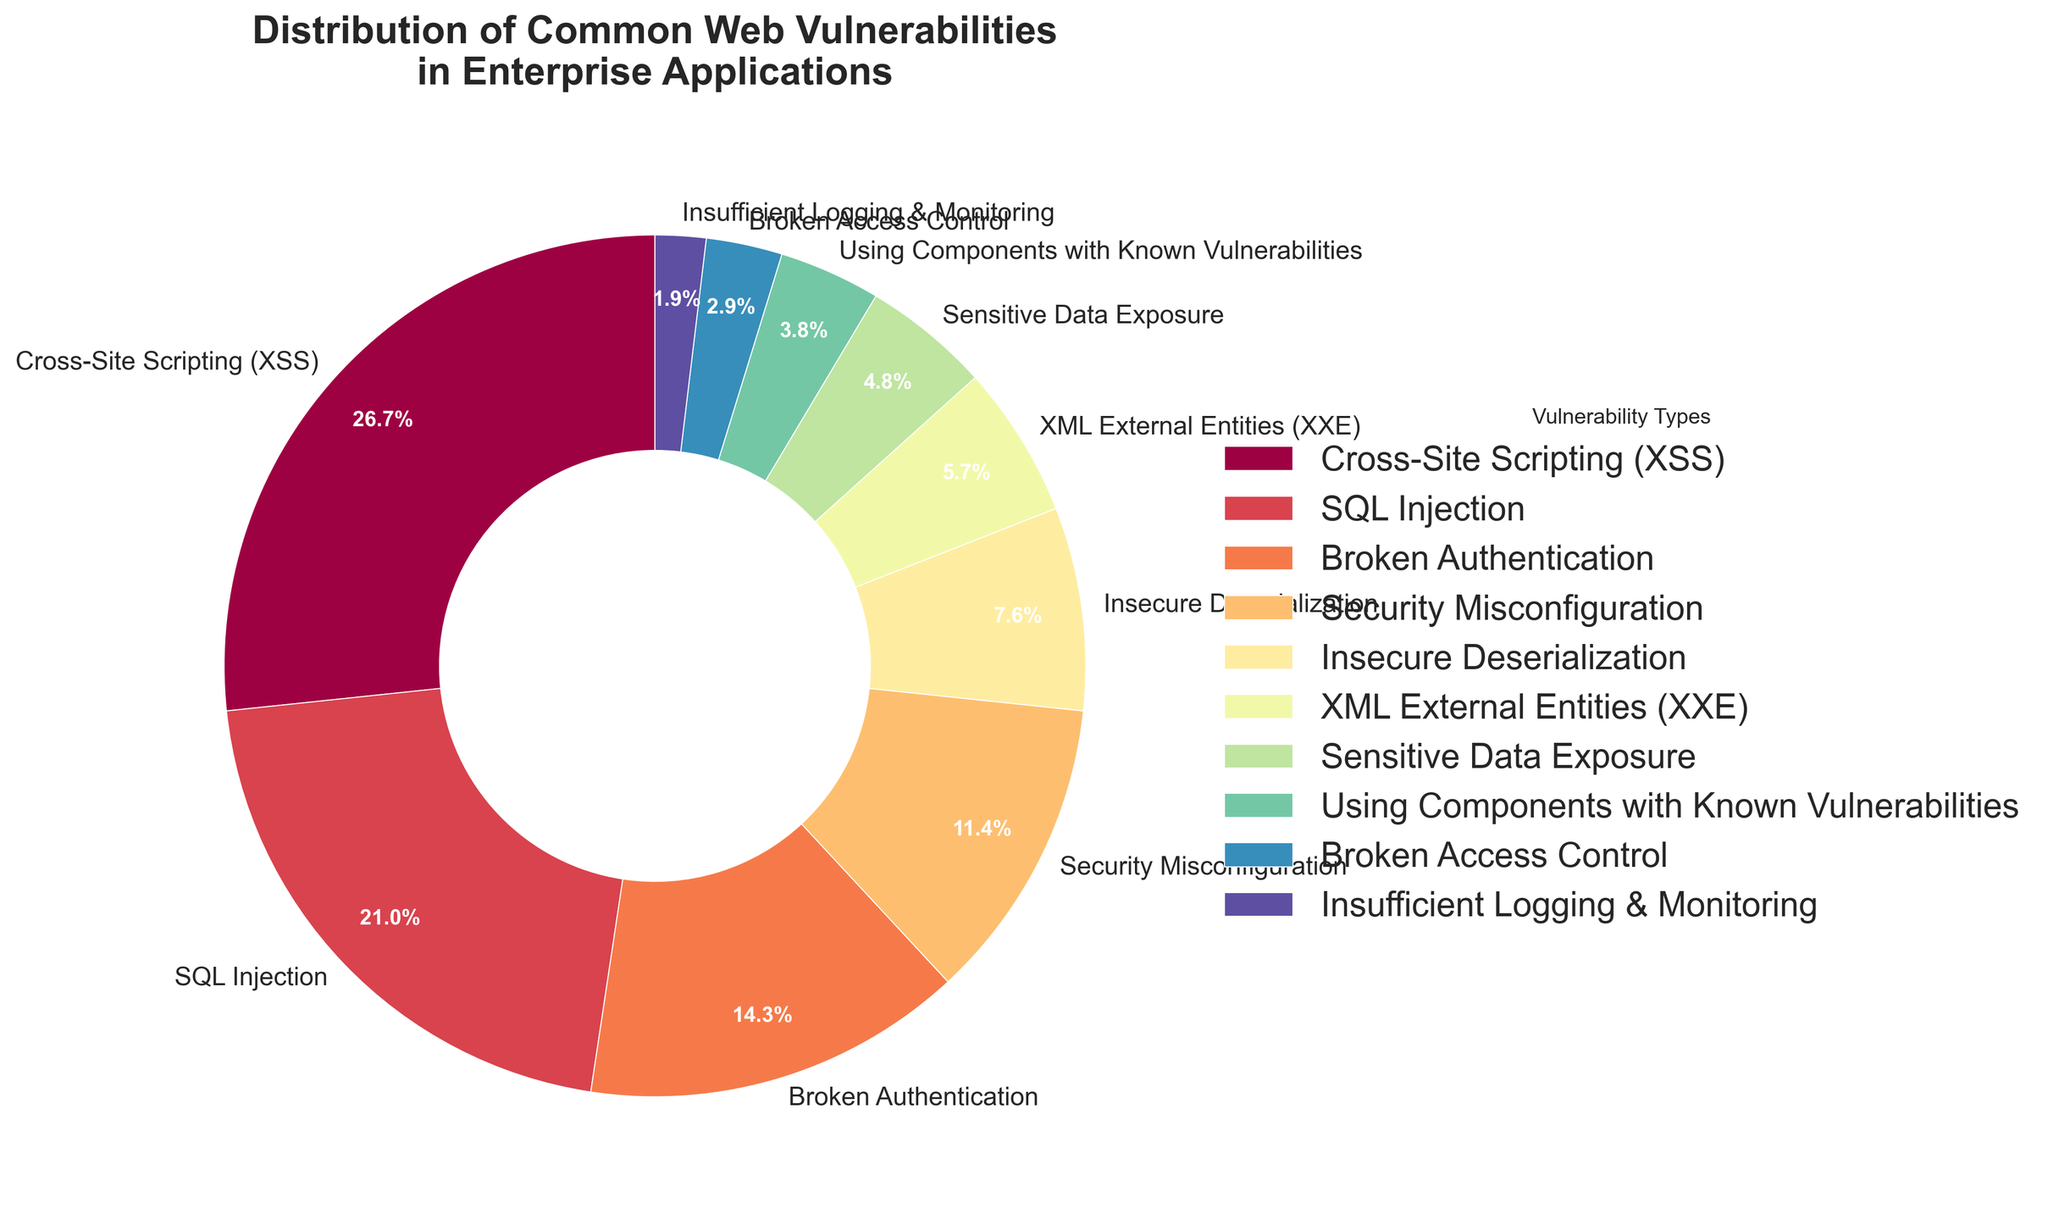What percentage of total vulnerabilities do Cross-Site Scripting (XSS) and SQL Injection together comprise? To find the combined percentage of Cross-Site Scripting (XSS) and SQL Injection, add their individual percentages: 28% (XSS) + 22% (SQL Injection).
Answer: 50% Which vulnerability type has the smallest representation in the pie chart? To find the smallest representation, look for the smallest percentage value in the figure. The smallest value is 2% for "Insufficient Logging & Monitoring".
Answer: Insufficient Logging & Monitoring How many vulnerability types have representations greater than 10%? To find the number of vulnerability types greater than 10%, count the segments in the pie chart with percentages higher than 10%. These are Cross-Site Scripting (28%), SQL Injection (22%), Broken Authentication (15%), and Security Misconfiguration (12%). So, there are 4 types.
Answer: 4 What is the difference in percentage between 'Broken Authentication' and 'Insecure Deserialization'? The percentage for Broken Authentication is 15% and for Insecure Deserialization is 8%. Subtract the smaller value from the larger one: 15% - 8% = 7%.
Answer: 7% Which two vulnerability types together account for more than 40% of the vulnerabilities? First, identify all vulnerability types and their percentages. Then sum the notable pairs. Cross-Site Scripting (28%) and SQL Injection (22%) combined are 50%, which is more than 40%.
Answer: Cross-Site Scripting and SQL Injection What percentage is represented by the four least common vulnerabilities combined? The four least common are: Broken Access Control (3%), Insufficient Logging & Monitoring (2%), Sensitive Data Exposure (5%), and Using Components with Known Vulnerabilities (4%). Their combined percentage is 3% + 2% + 5% + 4% = 14%.
Answer: 14% Which vulnerability type has approximately half the representation of 'Cross-Site Scripting (XSS)'? Cross-Site Scripting (XSS) represents 28%. Approximately half of 28% is 14%. The closest representation is 'Broken Authentication' at 15%.
Answer: Broken Authentication Arrange the vulnerability types in descending order of their representation. To arrange the vulnerabilities in descending order, list them by their percentage values from highest to lowest: Cross-Site Scripting (28%), SQL Injection (22%), Broken Authentication (15%), Security Misconfiguration (12%), Insecure Deserialization (8%), XML External Entities (6%), Sensitive Data Exposure (5%), Using Components with Known Vulnerabilities (4%), Broken Access Control (3%), Insufficient Logging & Monitoring (2%).
Answer: Cross-Site Scripting, SQL Injection, Broken Authentication, Security Misconfiguration, Insecure Deserialization, XML External Entities, Sensitive Data Exposure, Using Components with Known Vulnerabilities, Broken Access Control, Insufficient Logging & Monitoring What is the average percentage of 'XML External Entities' and 'Sensitive Data Exposure'? The percentages for 'XML External Entities' and 'Sensitive Data Exposure' are 6% and 5% respectively. To find the average, add the two percentages and then divide by 2: (6% + 5%) / 2 = 5.5%.
Answer: 5.5% Which color is associated with 'Broken Access Control' in the pie chart? To find the color associated with 'Broken Access Control', look at the visual attribute (color) associated with the label 'Broken Access Control' in the pie chart. The color is [describe the color based on the figure; e.g., light blue].
Answer: [describe color] 